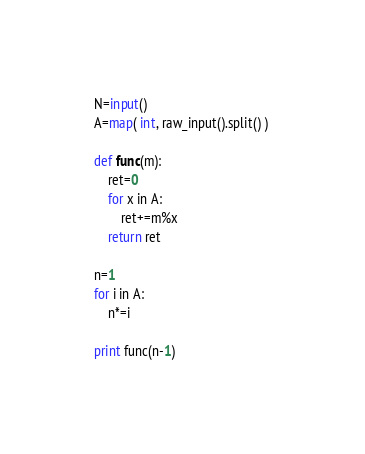Convert code to text. <code><loc_0><loc_0><loc_500><loc_500><_Python_>N=input()
A=map( int, raw_input().split() ) 

def func(m):
	ret=0
	for x in A:
		ret+=m%x
	return ret

n=1
for i in A:
	n*=i

print func(n-1)</code> 